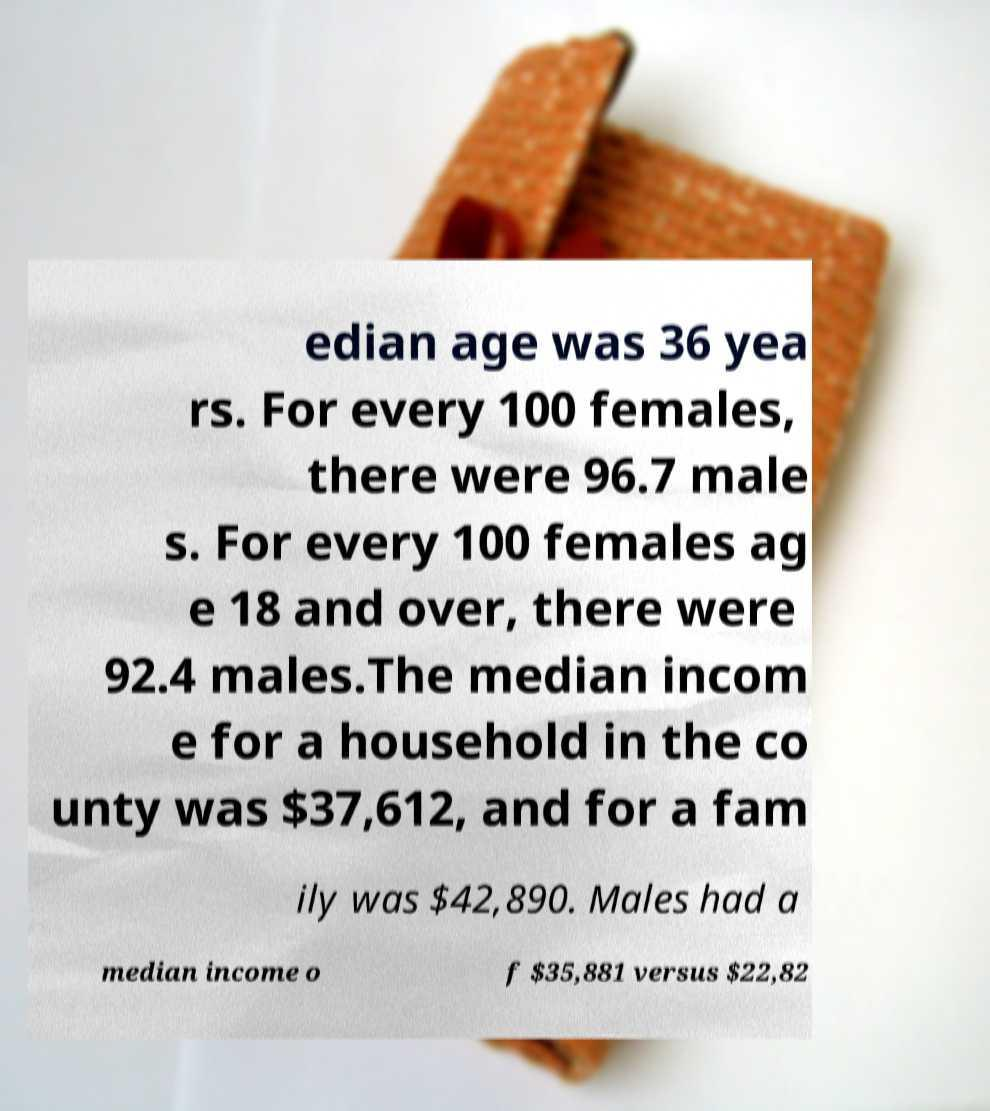Can you read and provide the text displayed in the image?This photo seems to have some interesting text. Can you extract and type it out for me? edian age was 36 yea rs. For every 100 females, there were 96.7 male s. For every 100 females ag e 18 and over, there were 92.4 males.The median incom e for a household in the co unty was $37,612, and for a fam ily was $42,890. Males had a median income o f $35,881 versus $22,82 